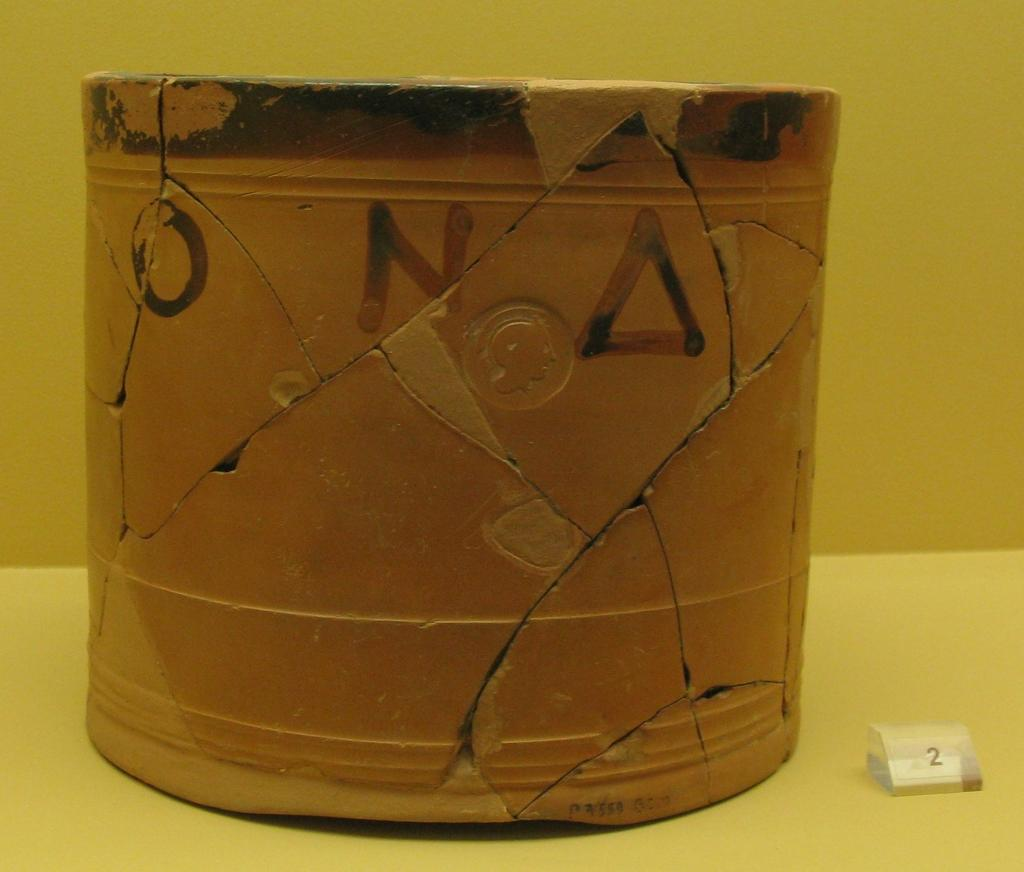Provide a one-sentence caption for the provided image. A cracked pot with the letters O, N and a triangle. 